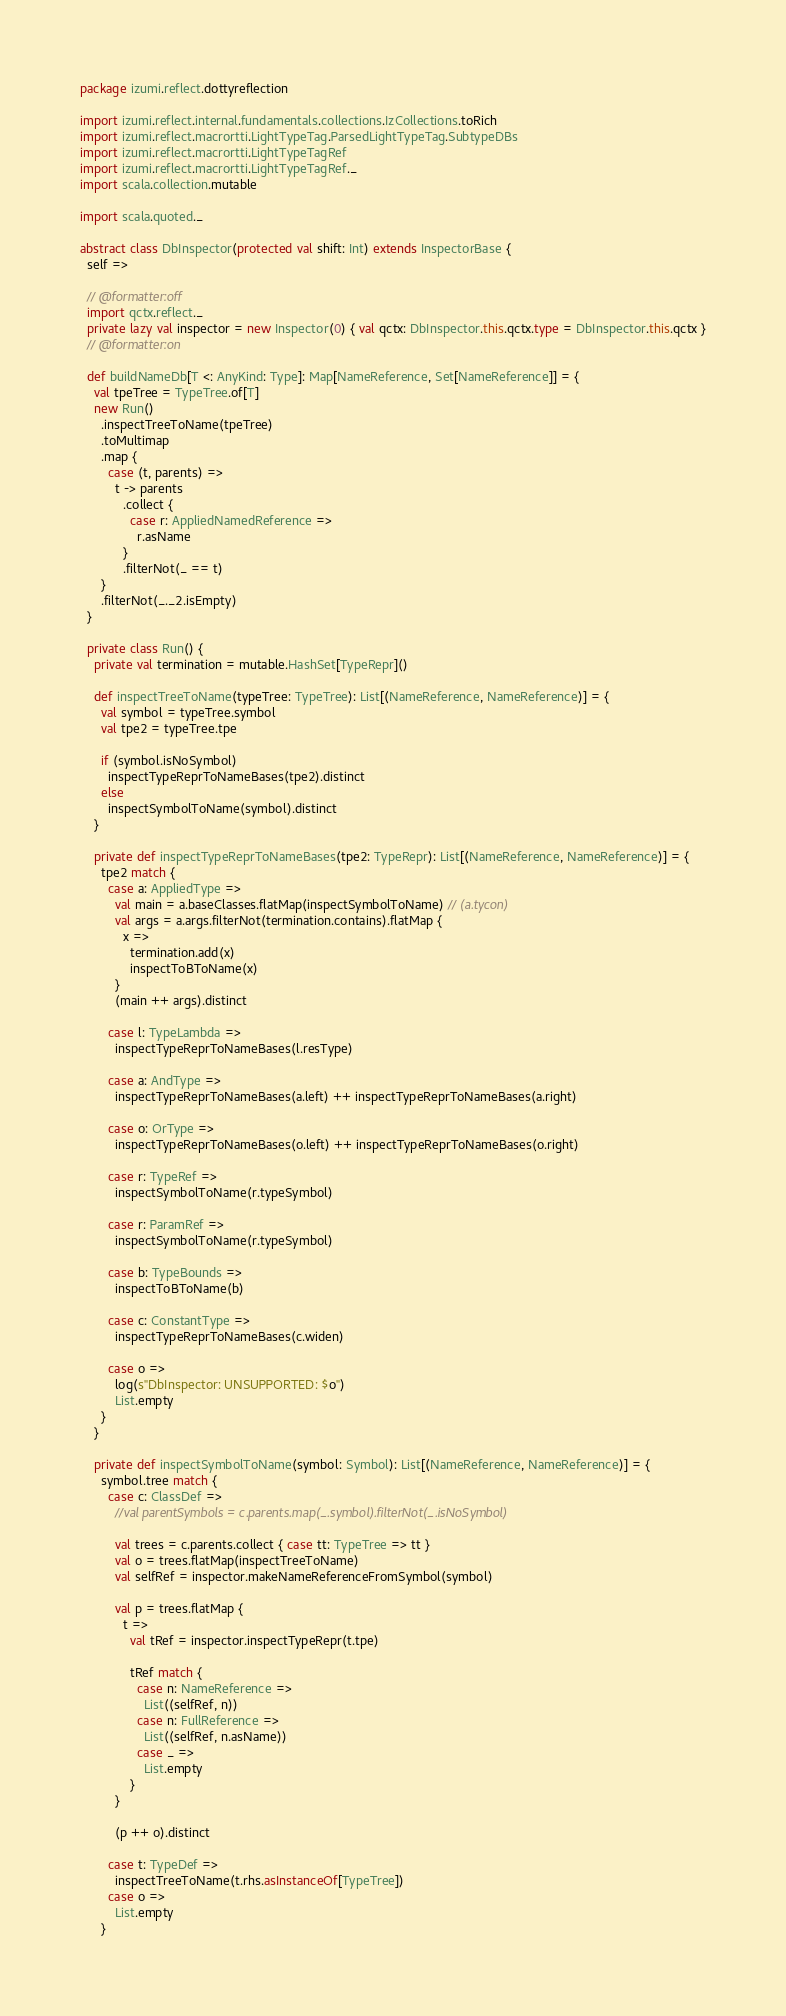<code> <loc_0><loc_0><loc_500><loc_500><_Scala_>package izumi.reflect.dottyreflection

import izumi.reflect.internal.fundamentals.collections.IzCollections.toRich
import izumi.reflect.macrortti.LightTypeTag.ParsedLightTypeTag.SubtypeDBs
import izumi.reflect.macrortti.LightTypeTagRef
import izumi.reflect.macrortti.LightTypeTagRef._
import scala.collection.mutable

import scala.quoted._

abstract class DbInspector(protected val shift: Int) extends InspectorBase {
  self =>

  // @formatter:off
  import qctx.reflect._
  private lazy val inspector = new Inspector(0) { val qctx: DbInspector.this.qctx.type = DbInspector.this.qctx }
  // @formatter:on

  def buildNameDb[T <: AnyKind: Type]: Map[NameReference, Set[NameReference]] = {
    val tpeTree = TypeTree.of[T]
    new Run()
      .inspectTreeToName(tpeTree)
      .toMultimap
      .map {
        case (t, parents) =>
          t -> parents
            .collect {
              case r: AppliedNamedReference =>
                r.asName
            }
            .filterNot(_ == t)
      }
      .filterNot(_._2.isEmpty)
  }

  private class Run() {
    private val termination = mutable.HashSet[TypeRepr]()

    def inspectTreeToName(typeTree: TypeTree): List[(NameReference, NameReference)] = {
      val symbol = typeTree.symbol
      val tpe2 = typeTree.tpe

      if (symbol.isNoSymbol)
        inspectTypeReprToNameBases(tpe2).distinct
      else
        inspectSymbolToName(symbol).distinct
    }

    private def inspectTypeReprToNameBases(tpe2: TypeRepr): List[(NameReference, NameReference)] = {
      tpe2 match {
        case a: AppliedType =>
          val main = a.baseClasses.flatMap(inspectSymbolToName) // (a.tycon)
          val args = a.args.filterNot(termination.contains).flatMap {
            x =>
              termination.add(x)
              inspectToBToName(x)
          }
          (main ++ args).distinct

        case l: TypeLambda =>
          inspectTypeReprToNameBases(l.resType)

        case a: AndType =>
          inspectTypeReprToNameBases(a.left) ++ inspectTypeReprToNameBases(a.right)

        case o: OrType =>
          inspectTypeReprToNameBases(o.left) ++ inspectTypeReprToNameBases(o.right)

        case r: TypeRef =>
          inspectSymbolToName(r.typeSymbol)

        case r: ParamRef =>
          inspectSymbolToName(r.typeSymbol)

        case b: TypeBounds =>
          inspectToBToName(b)

        case c: ConstantType =>
          inspectTypeReprToNameBases(c.widen)

        case o =>
          log(s"DbInspector: UNSUPPORTED: $o")
          List.empty
      }
    }

    private def inspectSymbolToName(symbol: Symbol): List[(NameReference, NameReference)] = {
      symbol.tree match {
        case c: ClassDef =>
          //val parentSymbols = c.parents.map(_.symbol).filterNot(_.isNoSymbol)

          val trees = c.parents.collect { case tt: TypeTree => tt }
          val o = trees.flatMap(inspectTreeToName)
          val selfRef = inspector.makeNameReferenceFromSymbol(symbol)

          val p = trees.flatMap {
            t =>
              val tRef = inspector.inspectTypeRepr(t.tpe)

              tRef match {
                case n: NameReference =>
                  List((selfRef, n))
                case n: FullReference =>
                  List((selfRef, n.asName))
                case _ =>
                  List.empty
              }
          }

          (p ++ o).distinct

        case t: TypeDef =>
          inspectTreeToName(t.rhs.asInstanceOf[TypeTree])
        case o =>
          List.empty
      }</code> 